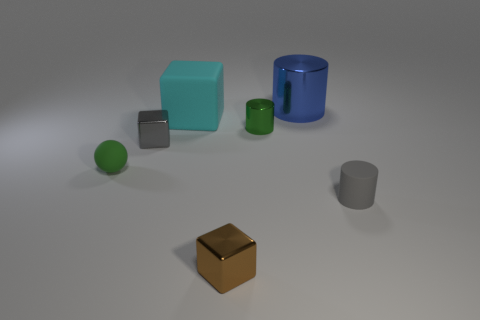What is the shape of the rubber object that is the same size as the gray cylinder?
Your answer should be very brief. Sphere. Do the cyan rubber object and the small green shiny object have the same shape?
Provide a succinct answer. No. What number of small brown metal objects are the same shape as the large shiny thing?
Offer a terse response. 0. What number of tiny matte objects are on the right side of the gray metal object?
Provide a short and direct response. 1. Is the color of the small metal block right of the large matte object the same as the small shiny cylinder?
Give a very brief answer. No. What number of metal things are the same size as the cyan matte cube?
Provide a succinct answer. 1. The small gray thing that is made of the same material as the big cyan thing is what shape?
Your response must be concise. Cylinder. Are there any rubber cubes of the same color as the small matte sphere?
Your answer should be compact. No. What material is the tiny ball?
Provide a succinct answer. Rubber. How many things are either small yellow spheres or big cyan blocks?
Make the answer very short. 1. 